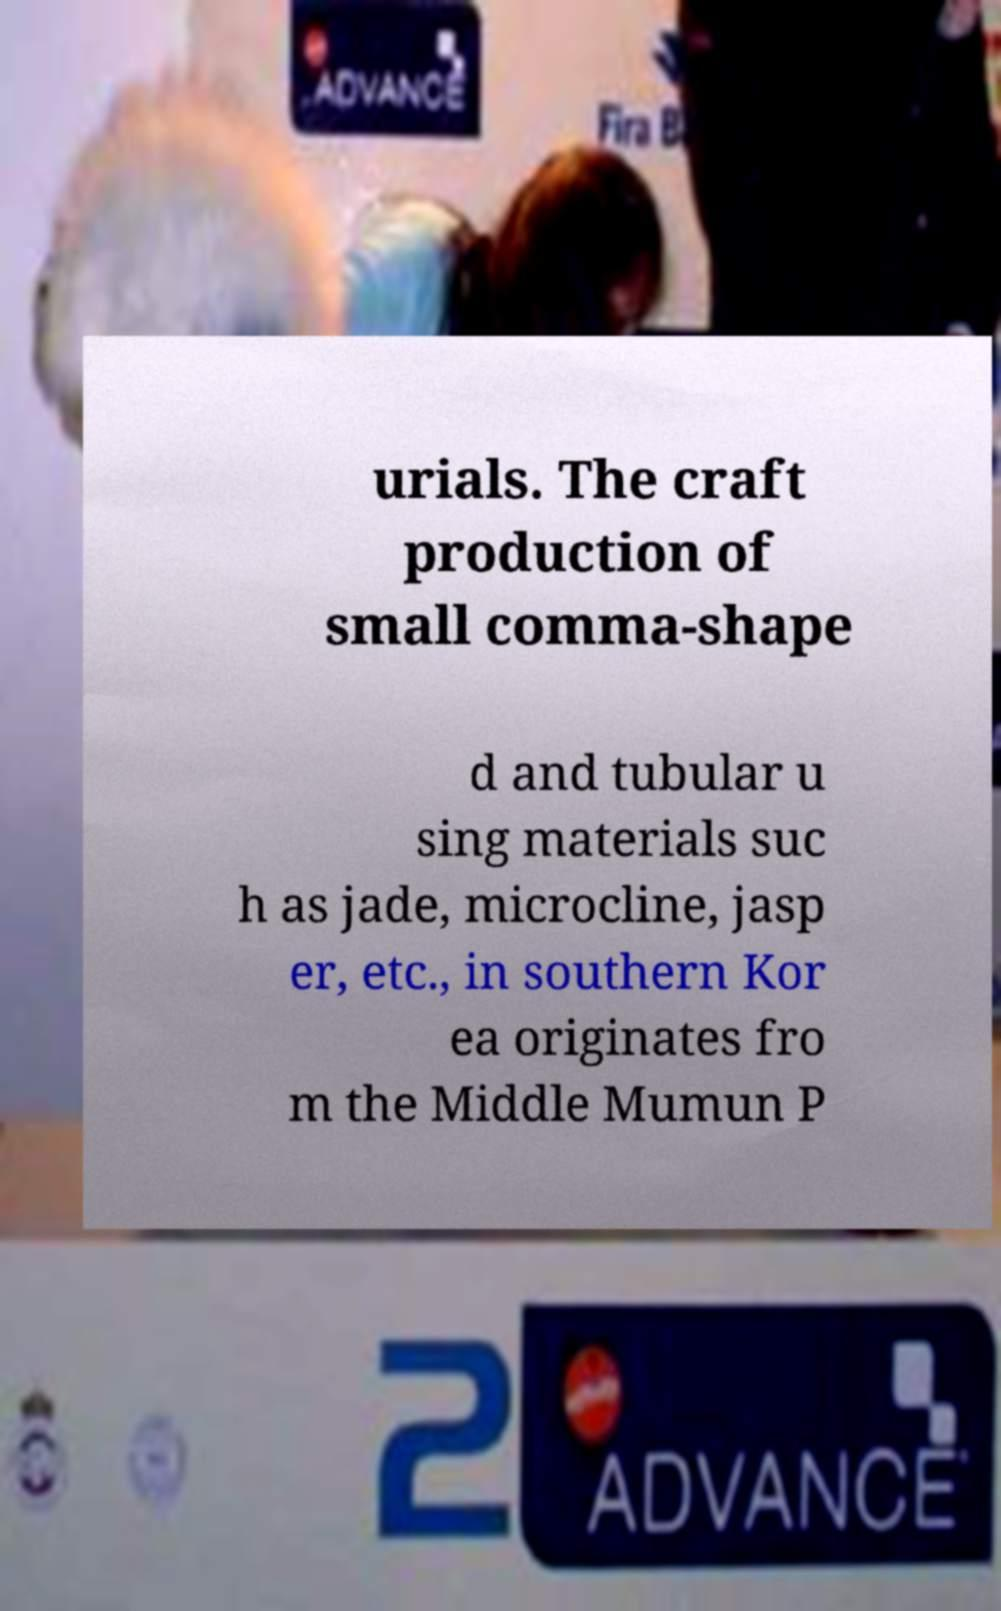There's text embedded in this image that I need extracted. Can you transcribe it verbatim? urials. The craft production of small comma-shape d and tubular u sing materials suc h as jade, microcline, jasp er, etc., in southern Kor ea originates fro m the Middle Mumun P 